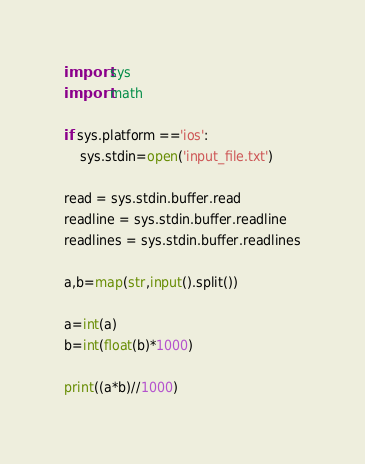Convert code to text. <code><loc_0><loc_0><loc_500><loc_500><_Python_>import sys
import math

if sys.platform =='ios':
    sys.stdin=open('input_file.txt')
   
read = sys.stdin.buffer.read
readline = sys.stdin.buffer.readline
readlines = sys.stdin.buffer.readlines

a,b=map(str,input().split())

a=int(a)
b=int(float(b)*1000)

print((a*b)//1000)
</code> 